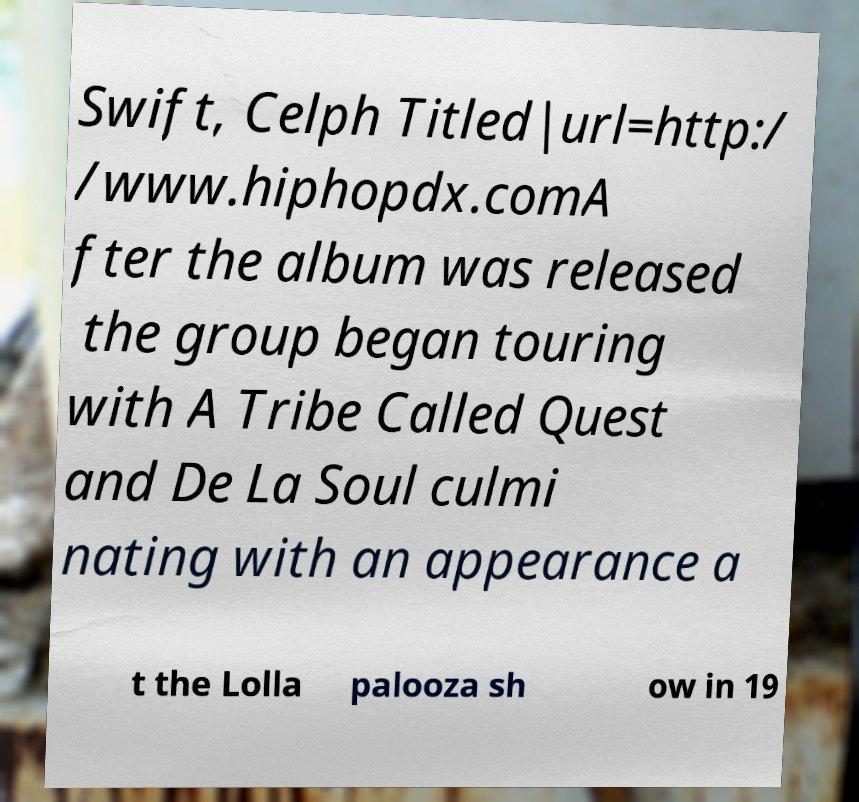What messages or text are displayed in this image? I need them in a readable, typed format. Swift, Celph Titled|url=http:/ /www.hiphopdx.comA fter the album was released the group began touring with A Tribe Called Quest and De La Soul culmi nating with an appearance a t the Lolla palooza sh ow in 19 